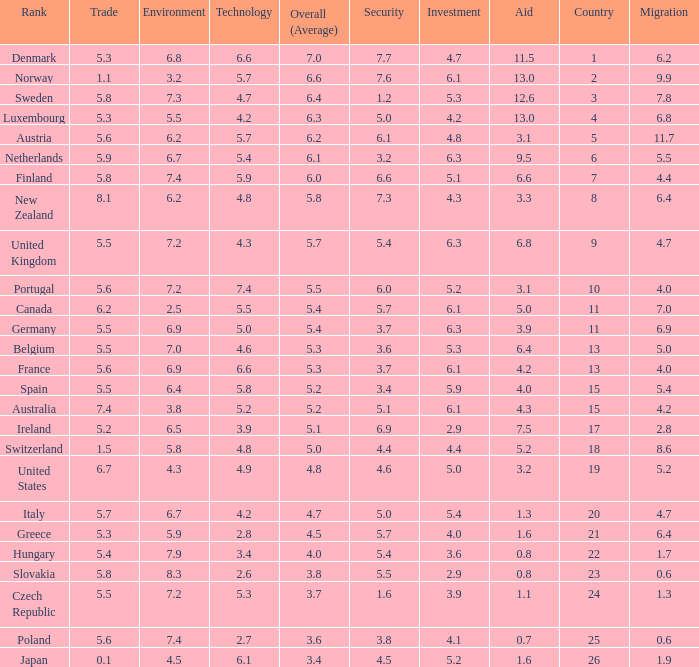What is the environment rating of the country with an overall average rating of 4.7? 6.7. 